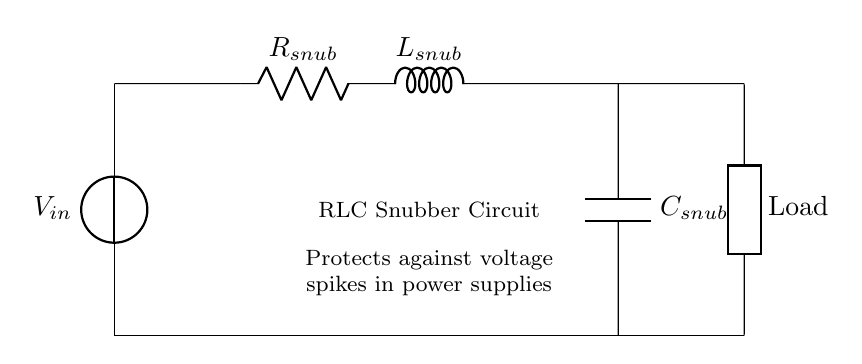What components are present in the circuit? The circuit includes a resistor, an inductor, and a capacitor, which are labeled as R, L, and C respectively. These components work together to form an RLC snubber circuit.
Answer: Resistor, Inductor, Capacitor What is the purpose of this circuit? The circuit is specifically designed to protect electronic components from voltage spikes in power supplies, as noted in the diagram with the description.
Answer: Protects against voltage spikes What is the order of components from input to output? The components are connected in a specific sequence starting from the voltage source, then passing through the resistor, inductor, and capacitor before going to the load.
Answer: Voltage source, Resistor, Inductor, Capacitor, Load What could happen if the RLC snubber circuit is not used? Without the RLC snubber circuit, voltage spikes could cause damage to sensitive components, leading to failure or reduced lifespan of the electronic devices.
Answer: Component damage How do the components in the RLC snubber impact voltage spikes? The resistor dissipates energy, the inductor helps to limit the rate of change of current, and the capacitor absorbs excess voltage, thus protecting the load from spikes.
Answer: Limits voltage spikes What happens when the inductor in the circuit operates during a voltage spike? The inductor resists changes in current, which helps in smoothing out the spike by opposing rapid changes, leading to a gradual increase and decrease in current.
Answer: Opposes changes in current 